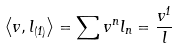Convert formula to latex. <formula><loc_0><loc_0><loc_500><loc_500>\left \langle v , l _ { ( 1 ) } \right \rangle = \sum v ^ { n } l _ { n } = \frac { v ^ { 1 } } { l }</formula> 